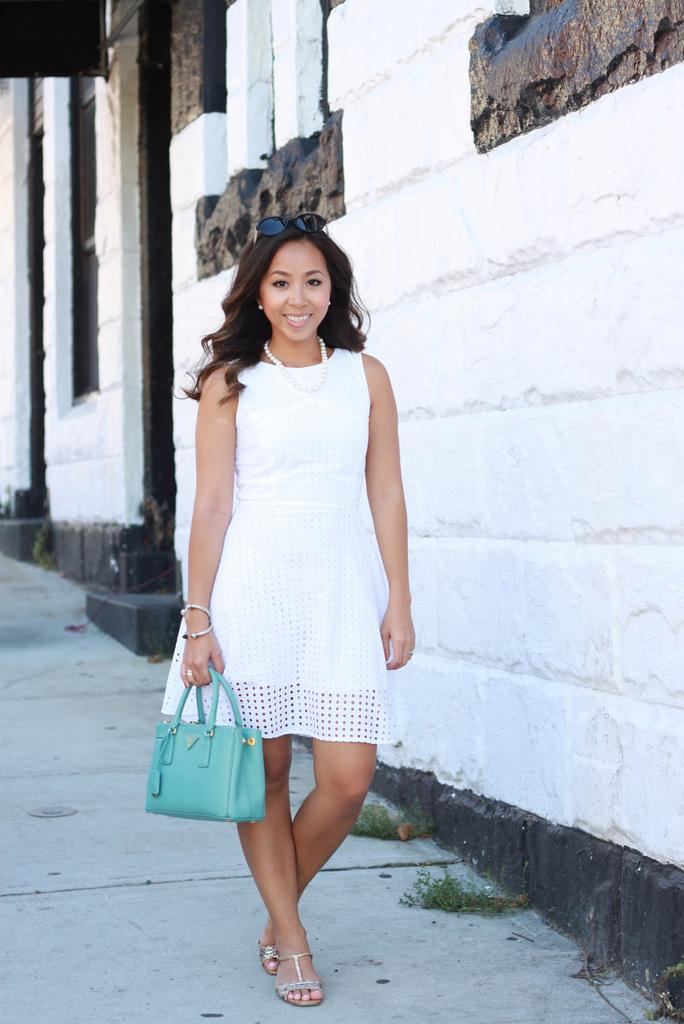What is the gender of the person in the image? The person in the image is a lady. What is the lady person wearing in the image? The lady person is wearing a white dress. Where is the lady person standing in the image? The lady person is standing on the floor. What is the lady person holding in her right hand? The lady person is holding a handbag in her right hand. What can be seen in the background of the image? There is a wall in the background of the image. How many cows are visible in the image? There are no cows present in the image. What type of brick is the lady person standing on in the image? The lady person is standing on the floor, not on any brick. 